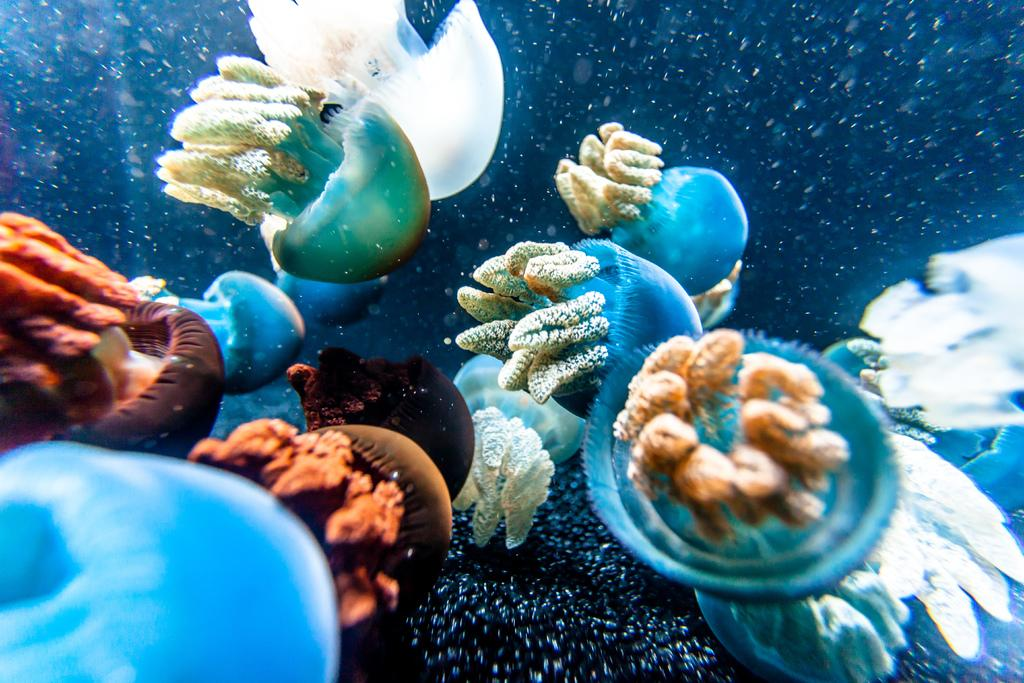What type of animals can be seen in the water in the image? There are jellyfishes in the water in the image. What distinguishing feature can be observed about the jellyfishes? The jellyfishes are in different colors. What is the color of the background in the image? The background of the image is violet in color. What type of oatmeal is being served in the image? There is no oatmeal present in the image; it features jellyfishes in the water. What is the weather like in the image? The provided facts do not mention the weather, so it cannot be determined from the image. 